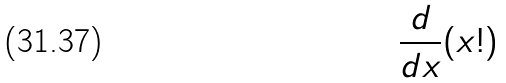<formula> <loc_0><loc_0><loc_500><loc_500>\frac { d } { d x } ( x ! )</formula> 